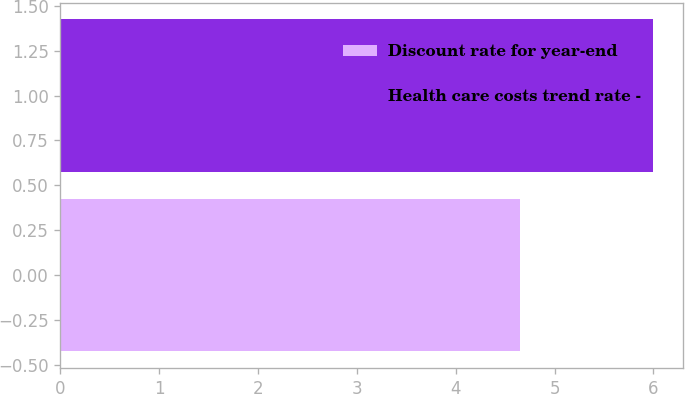Convert chart to OTSL. <chart><loc_0><loc_0><loc_500><loc_500><bar_chart><fcel>Discount rate for year-end<fcel>Health care costs trend rate -<nl><fcel>4.65<fcel>6<nl></chart> 